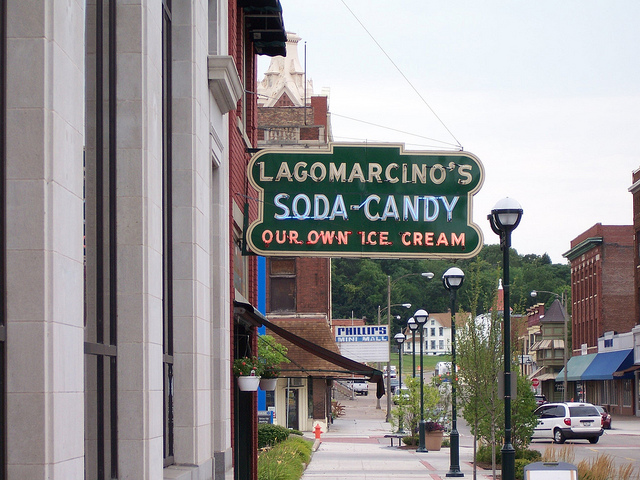Read all the text in this image. LAGOMARCINO'S SODA CANDY OUR OWN ICE CREAM PHILLIPS MINI MALL 